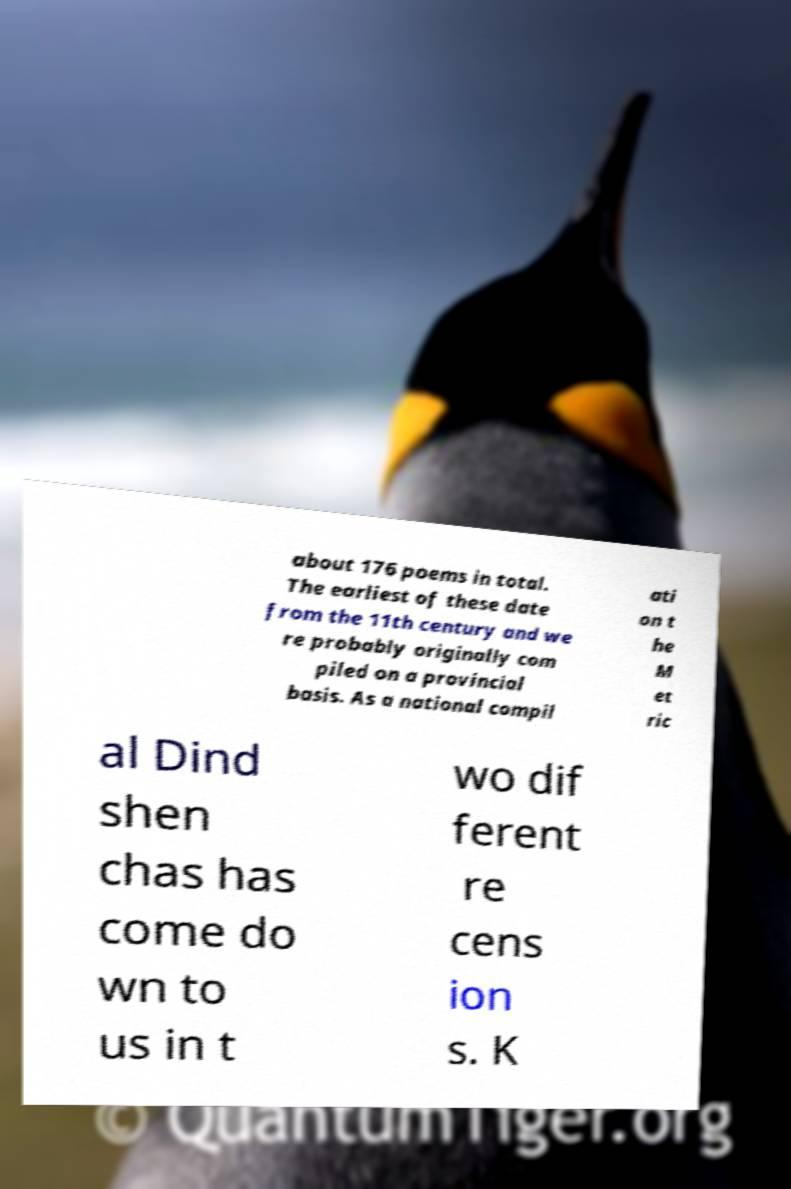Please identify and transcribe the text found in this image. about 176 poems in total. The earliest of these date from the 11th century and we re probably originally com piled on a provincial basis. As a national compil ati on t he M et ric al Dind shen chas has come do wn to us in t wo dif ferent re cens ion s. K 